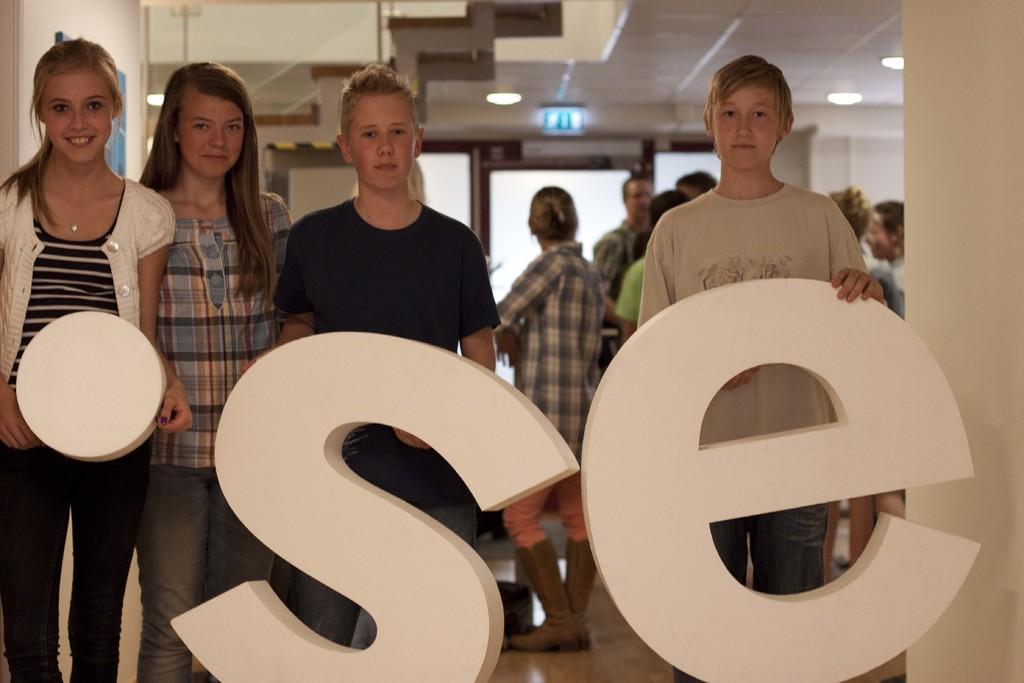Describe this image in one or two sentences. In this image, there are a few people. Among them, some people are holding objects. We can see the ground and the wall. We can also see some boards. We can see some white colored objects in the background. We can see the roof with some lights. 